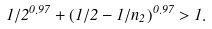Convert formula to latex. <formula><loc_0><loc_0><loc_500><loc_500>1 / 2 ^ { 0 . 9 7 } + ( 1 / 2 - 1 / n _ { 2 } ) ^ { 0 . 9 7 } > 1 .</formula> 